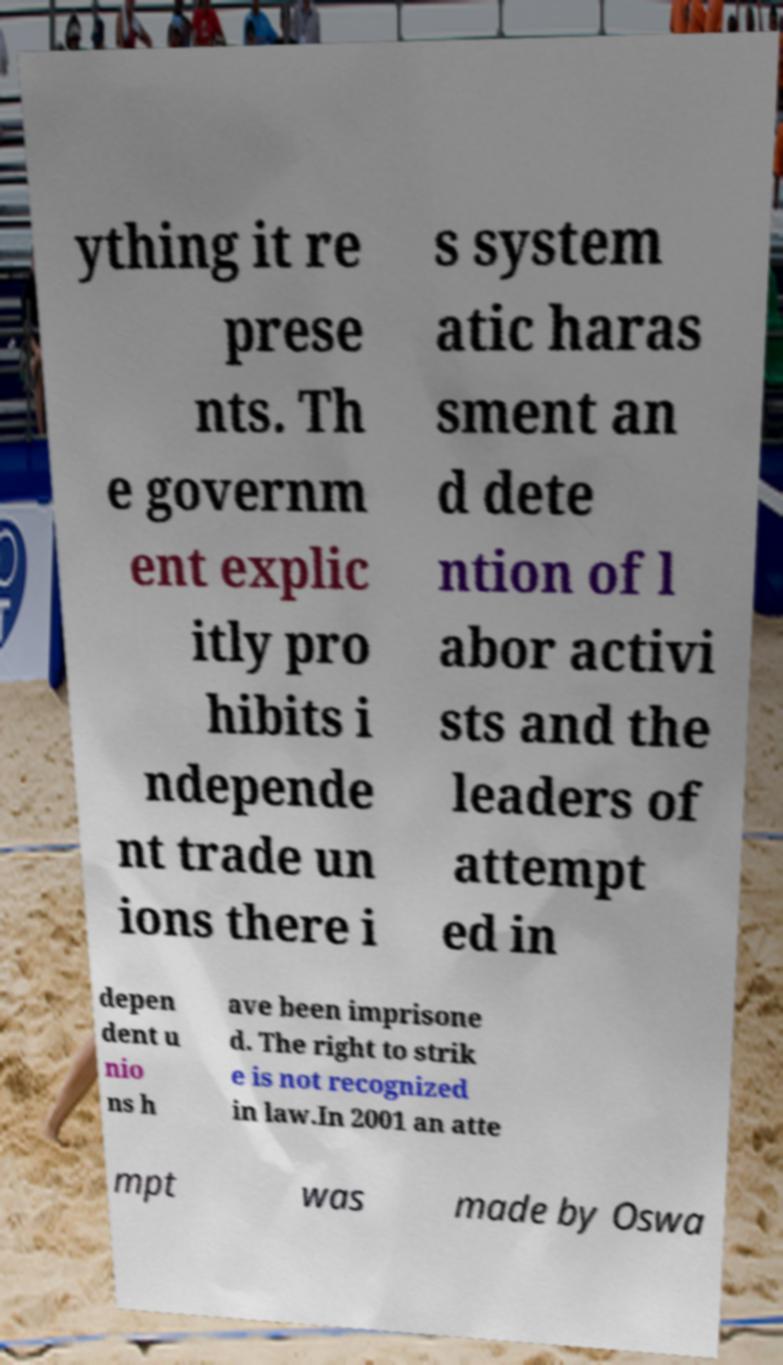Please identify and transcribe the text found in this image. ything it re prese nts. Th e governm ent explic itly pro hibits i ndepende nt trade un ions there i s system atic haras sment an d dete ntion of l abor activi sts and the leaders of attempt ed in depen dent u nio ns h ave been imprisone d. The right to strik e is not recognized in law.In 2001 an atte mpt was made by Oswa 